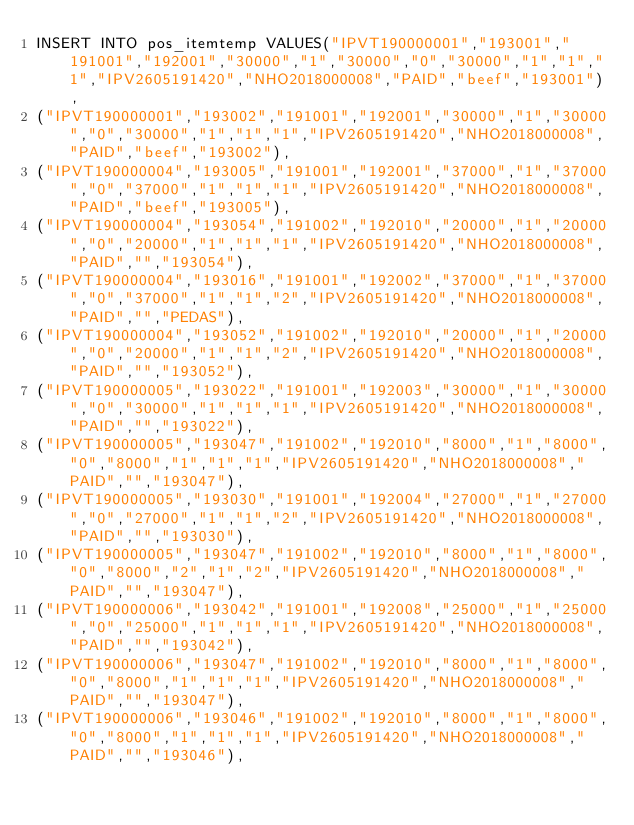Convert code to text. <code><loc_0><loc_0><loc_500><loc_500><_SQL_>INSERT INTO pos_itemtemp VALUES("IPVT190000001","193001","191001","192001","30000","1","30000","0","30000","1","1","1","IPV2605191420","NHO2018000008","PAID","beef","193001"),
("IPVT190000001","193002","191001","192001","30000","1","30000","0","30000","1","1","1","IPV2605191420","NHO2018000008","PAID","beef","193002"),
("IPVT190000004","193005","191001","192001","37000","1","37000","0","37000","1","1","1","IPV2605191420","NHO2018000008","PAID","beef","193005"),
("IPVT190000004","193054","191002","192010","20000","1","20000","0","20000","1","1","1","IPV2605191420","NHO2018000008","PAID","","193054"),
("IPVT190000004","193016","191001","192002","37000","1","37000","0","37000","1","1","2","IPV2605191420","NHO2018000008","PAID","","PEDAS"),
("IPVT190000004","193052","191002","192010","20000","1","20000","0","20000","1","1","2","IPV2605191420","NHO2018000008","PAID","","193052"),
("IPVT190000005","193022","191001","192003","30000","1","30000","0","30000","1","1","1","IPV2605191420","NHO2018000008","PAID","","193022"),
("IPVT190000005","193047","191002","192010","8000","1","8000","0","8000","1","1","1","IPV2605191420","NHO2018000008","PAID","","193047"),
("IPVT190000005","193030","191001","192004","27000","1","27000","0","27000","1","1","2","IPV2605191420","NHO2018000008","PAID","","193030"),
("IPVT190000005","193047","191002","192010","8000","1","8000","0","8000","2","1","2","IPV2605191420","NHO2018000008","PAID","","193047"),
("IPVT190000006","193042","191001","192008","25000","1","25000","0","25000","1","1","1","IPV2605191420","NHO2018000008","PAID","","193042"),
("IPVT190000006","193047","191002","192010","8000","1","8000","0","8000","1","1","1","IPV2605191420","NHO2018000008","PAID","","193047"),
("IPVT190000006","193046","191002","192010","8000","1","8000","0","8000","1","1","1","IPV2605191420","NHO2018000008","PAID","","193046"),</code> 